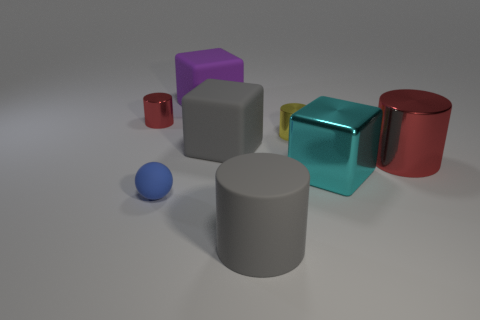Is the color of the matte cube in front of the large purple matte cube the same as the large matte cylinder that is on the left side of the large cyan metal thing?
Your answer should be very brief. Yes. Are there any red objects that have the same shape as the small yellow thing?
Keep it short and to the point. Yes. There is a metallic object that is the same size as the cyan cube; what shape is it?
Your answer should be very brief. Cylinder. What number of big metallic objects are the same color as the ball?
Offer a very short reply. 0. What size is the red shiny cylinder that is on the left side of the blue rubber sphere?
Make the answer very short. Small. How many yellow metal cylinders have the same size as the blue rubber ball?
Provide a short and direct response. 1. There is a tiny thing that is the same material as the gray cylinder; what color is it?
Your answer should be very brief. Blue. Are there fewer gray objects that are on the left side of the gray block than big cyan cylinders?
Offer a terse response. No. What is the shape of the purple object that is made of the same material as the tiny blue sphere?
Keep it short and to the point. Cube. How many rubber objects are either red cylinders or cyan blocks?
Your answer should be very brief. 0. 